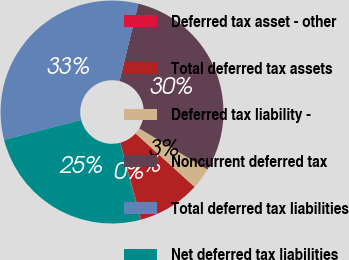Convert chart. <chart><loc_0><loc_0><loc_500><loc_500><pie_chart><fcel>Deferred tax asset - other<fcel>Total deferred tax assets<fcel>Deferred tax liability -<fcel>Noncurrent deferred tax<fcel>Total deferred tax liabilities<fcel>Net deferred tax liabilities<nl><fcel>0.11%<fcel>9.07%<fcel>3.09%<fcel>29.83%<fcel>32.82%<fcel>25.08%<nl></chart> 